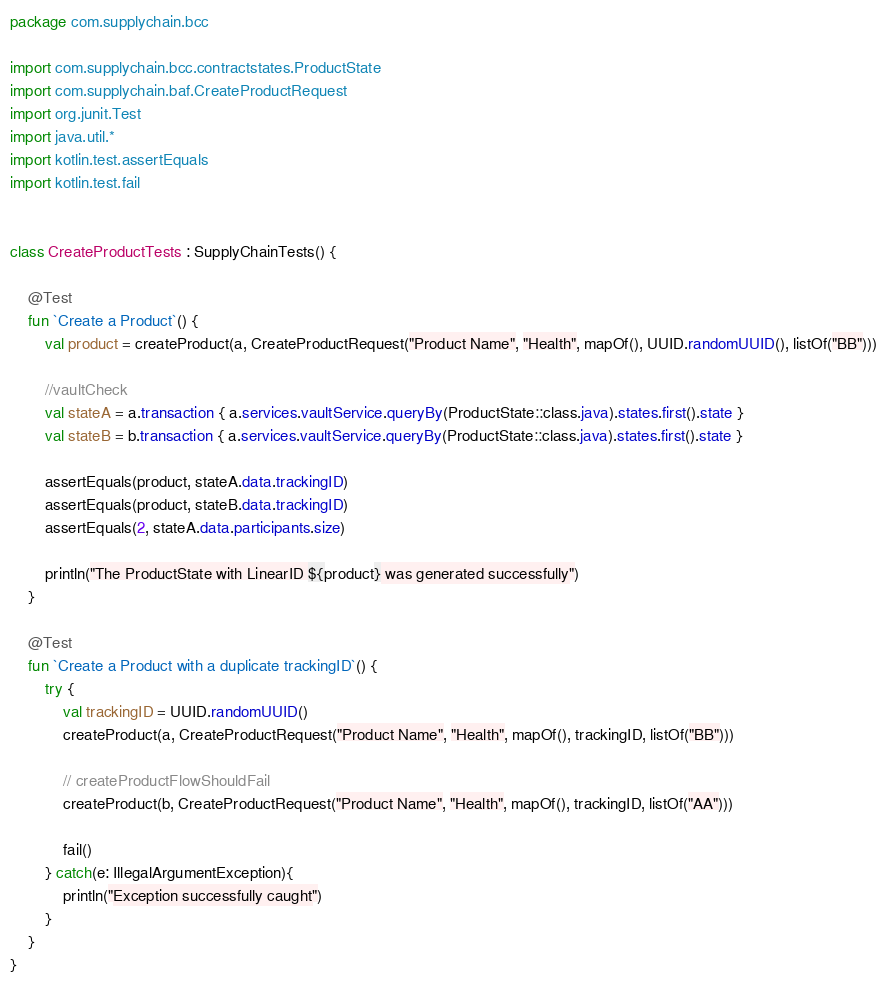Convert code to text. <code><loc_0><loc_0><loc_500><loc_500><_Kotlin_>package com.supplychain.bcc

import com.supplychain.bcc.contractstates.ProductState
import com.supplychain.baf.CreateProductRequest
import org.junit.Test
import java.util.*
import kotlin.test.assertEquals
import kotlin.test.fail


class CreateProductTests : SupplyChainTests() {

    @Test
    fun `Create a Product`() {
        val product = createProduct(a, CreateProductRequest("Product Name", "Health", mapOf(), UUID.randomUUID(), listOf("BB")))

        //vaultCheck
        val stateA = a.transaction { a.services.vaultService.queryBy(ProductState::class.java).states.first().state }
        val stateB = b.transaction { a.services.vaultService.queryBy(ProductState::class.java).states.first().state }

        assertEquals(product, stateA.data.trackingID)
        assertEquals(product, stateB.data.trackingID)
        assertEquals(2, stateA.data.participants.size)

        println("The ProductState with LinearID ${product} was generated successfully")
    }

    @Test
    fun `Create a Product with a duplicate trackingID`() {
        try {
            val trackingID = UUID.randomUUID()
            createProduct(a, CreateProductRequest("Product Name", "Health", mapOf(), trackingID, listOf("BB")))

            // createProductFlowShouldFail
            createProduct(b, CreateProductRequest("Product Name", "Health", mapOf(), trackingID, listOf("AA")))

            fail()
        } catch(e: IllegalArgumentException){
            println("Exception successfully caught")
        }
    }
}</code> 